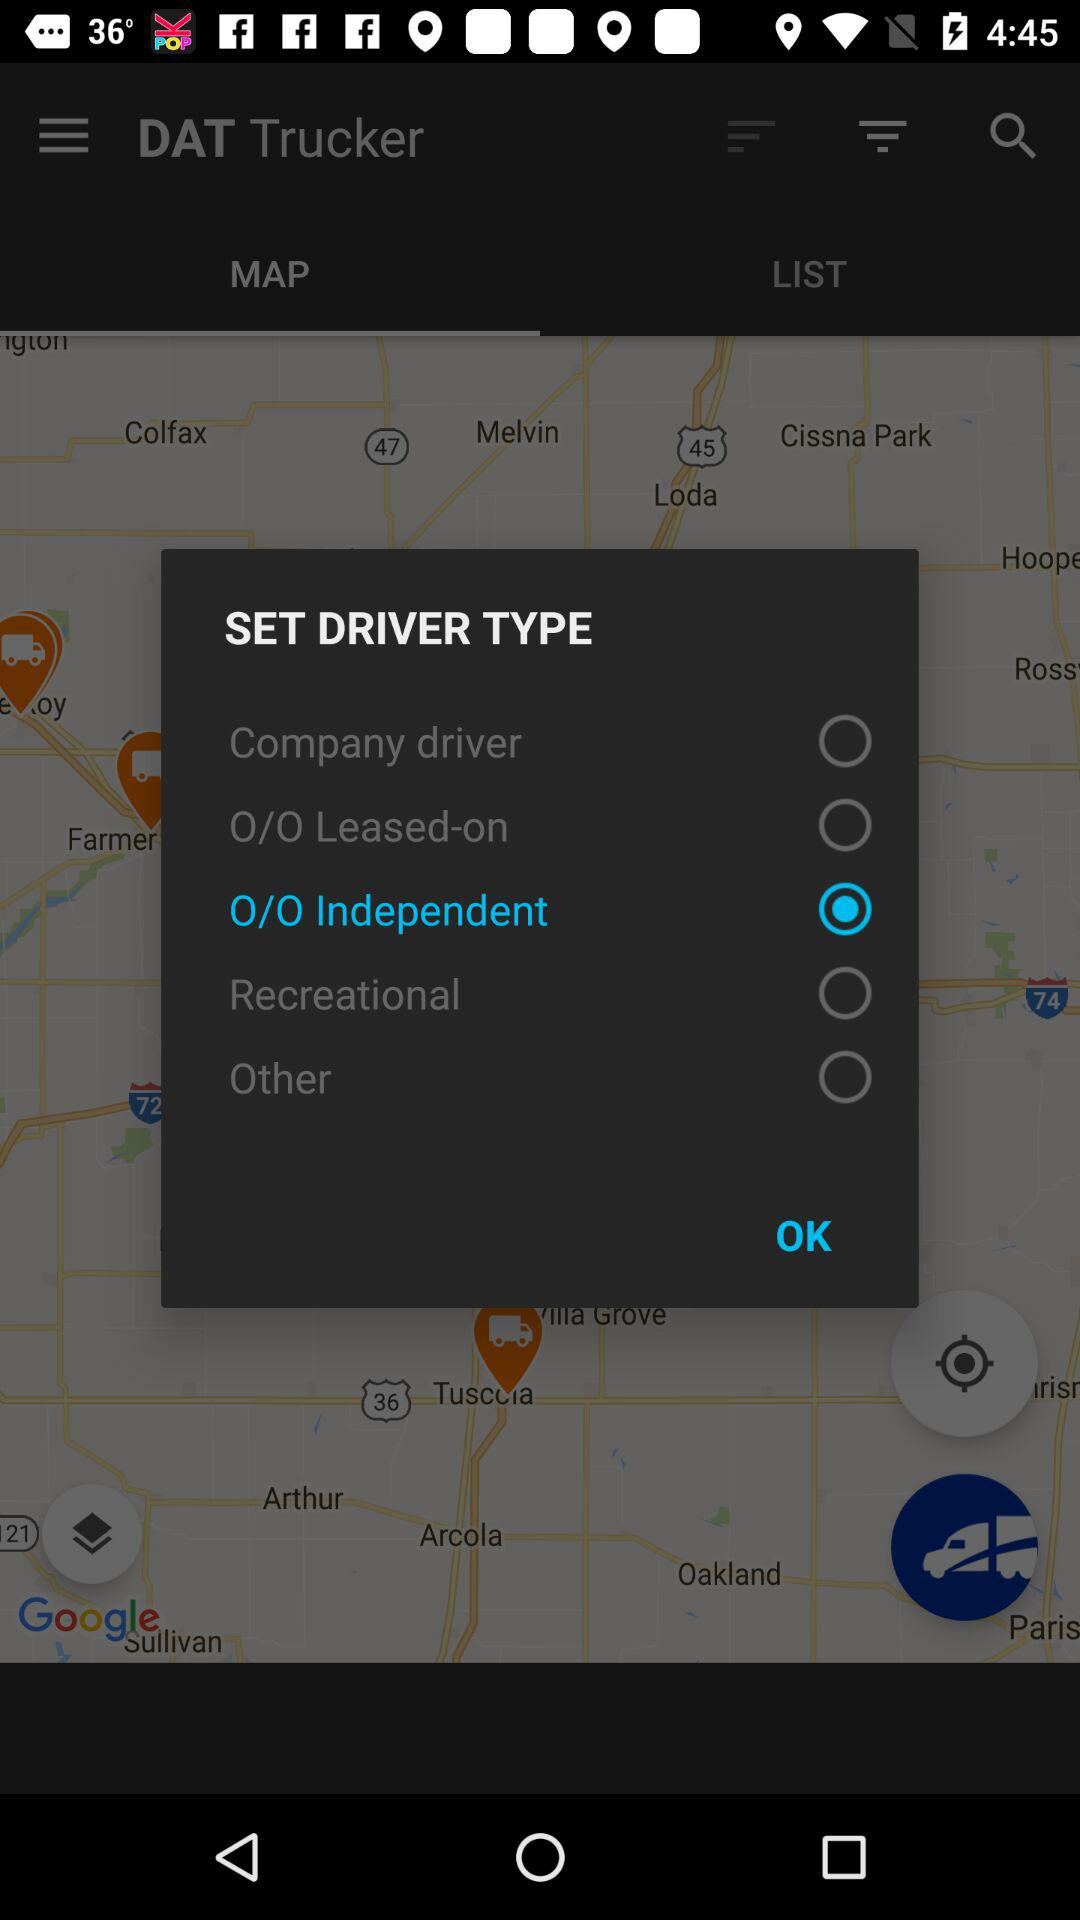Which driver type is selected? The selected driver type is "0/0 Independent". 